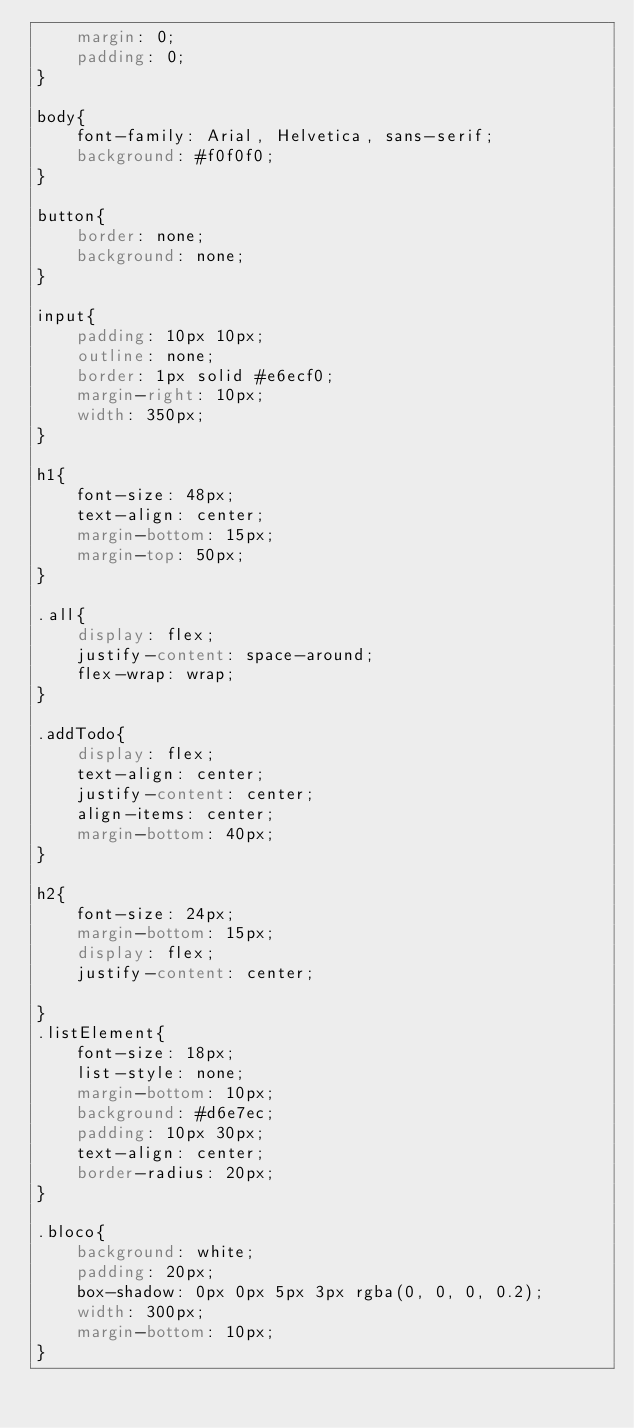<code> <loc_0><loc_0><loc_500><loc_500><_CSS_>    margin: 0;
    padding: 0;
}

body{
    font-family: Arial, Helvetica, sans-serif;
    background: #f0f0f0;
}

button{
    border: none;
    background: none;
}

input{
    padding: 10px 10px;
    outline: none;
    border: 1px solid #e6ecf0;
    margin-right: 10px;
    width: 350px;
}

h1{
    font-size: 48px;
    text-align: center;
    margin-bottom: 15px;
    margin-top: 50px;
}

.all{
    display: flex;
    justify-content: space-around;
    flex-wrap: wrap;
}

.addTodo{
    display: flex;
    text-align: center;
    justify-content: center;
    align-items: center;
    margin-bottom: 40px;
}

h2{
    font-size: 24px;
    margin-bottom: 15px;
    display: flex;
    justify-content: center;

}
.listElement{
    font-size: 18px;
    list-style: none;
    margin-bottom: 10px;
    background: #d6e7ec;
    padding: 10px 30px;
    text-align: center;
    border-radius: 20px;
}

.bloco{
    background: white;
    padding: 20px;
    box-shadow: 0px 0px 5px 3px rgba(0, 0, 0, 0.2);
    width: 300px;
    margin-bottom: 10px;
}</code> 